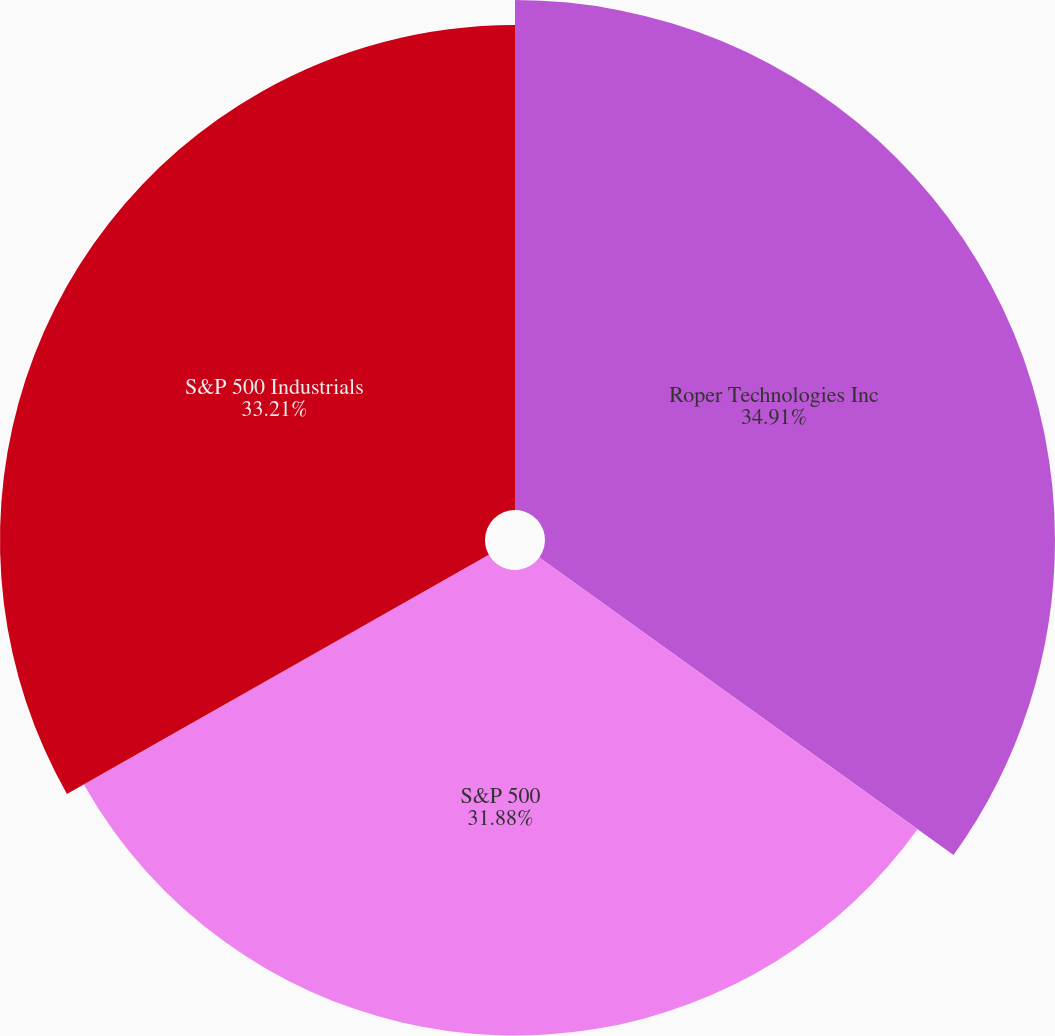Convert chart to OTSL. <chart><loc_0><loc_0><loc_500><loc_500><pie_chart><fcel>Roper Technologies Inc<fcel>S&P 500<fcel>S&P 500 Industrials<nl><fcel>34.92%<fcel>31.88%<fcel>33.21%<nl></chart> 